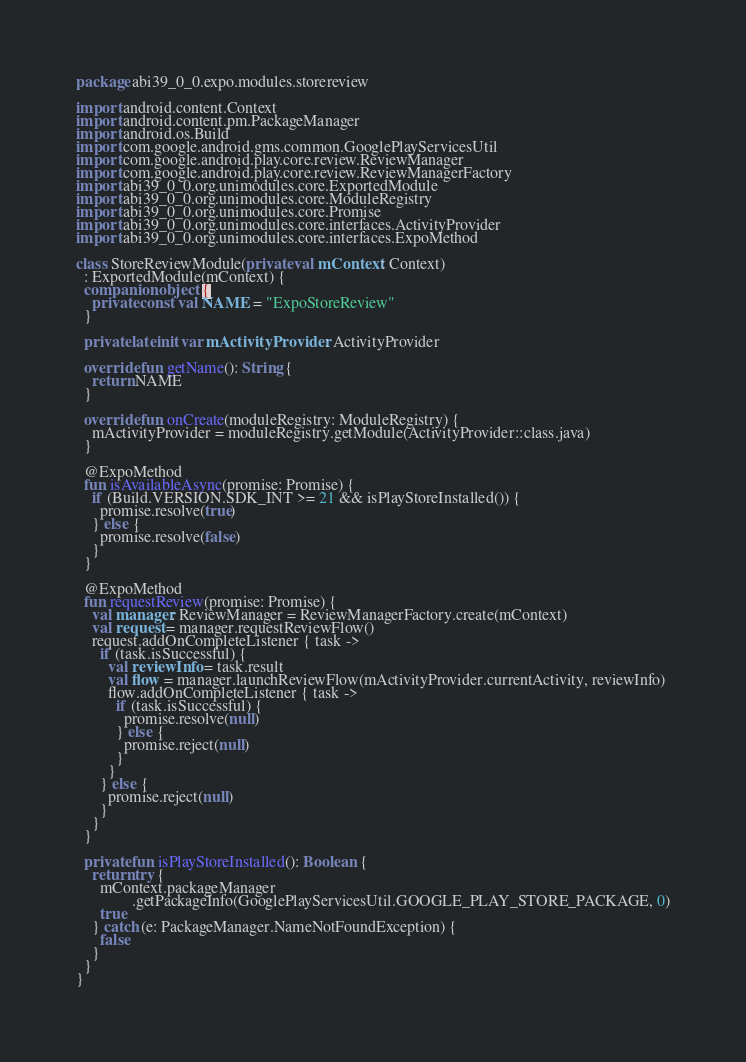Convert code to text. <code><loc_0><loc_0><loc_500><loc_500><_Kotlin_>package abi39_0_0.expo.modules.storereview

import android.content.Context
import android.content.pm.PackageManager
import android.os.Build
import com.google.android.gms.common.GooglePlayServicesUtil
import com.google.android.play.core.review.ReviewManager
import com.google.android.play.core.review.ReviewManagerFactory
import abi39_0_0.org.unimodules.core.ExportedModule
import abi39_0_0.org.unimodules.core.ModuleRegistry
import abi39_0_0.org.unimodules.core.Promise
import abi39_0_0.org.unimodules.core.interfaces.ActivityProvider
import abi39_0_0.org.unimodules.core.interfaces.ExpoMethod

class StoreReviewModule(private val mContext: Context)
  : ExportedModule(mContext) {
  companion object {
    private const val NAME = "ExpoStoreReview"
  }

  private lateinit var mActivityProvider: ActivityProvider

  override fun getName(): String {
    return NAME
  }

  override fun onCreate(moduleRegistry: ModuleRegistry) {
    mActivityProvider = moduleRegistry.getModule(ActivityProvider::class.java)
  }

  @ExpoMethod
  fun isAvailableAsync(promise: Promise) {
    if (Build.VERSION.SDK_INT >= 21 && isPlayStoreInstalled()) {
      promise.resolve(true)
    } else {
      promise.resolve(false)
    }
  }

  @ExpoMethod
  fun requestReview(promise: Promise) {
    val manager: ReviewManager = ReviewManagerFactory.create(mContext)
    val request = manager.requestReviewFlow()
    request.addOnCompleteListener { task ->
      if (task.isSuccessful) {
        val reviewInfo = task.result
        val flow = manager.launchReviewFlow(mActivityProvider.currentActivity, reviewInfo)
        flow.addOnCompleteListener { task ->
          if (task.isSuccessful) {
            promise.resolve(null)
          } else {
            promise.reject(null)
          }
        }
      } else {
        promise.reject(null)
      }
    }
  }

  private fun isPlayStoreInstalled(): Boolean {
    return try {
      mContext.packageManager
              .getPackageInfo(GooglePlayServicesUtil.GOOGLE_PLAY_STORE_PACKAGE, 0)
      true
    } catch (e: PackageManager.NameNotFoundException) {
      false
    }
  }
}
</code> 